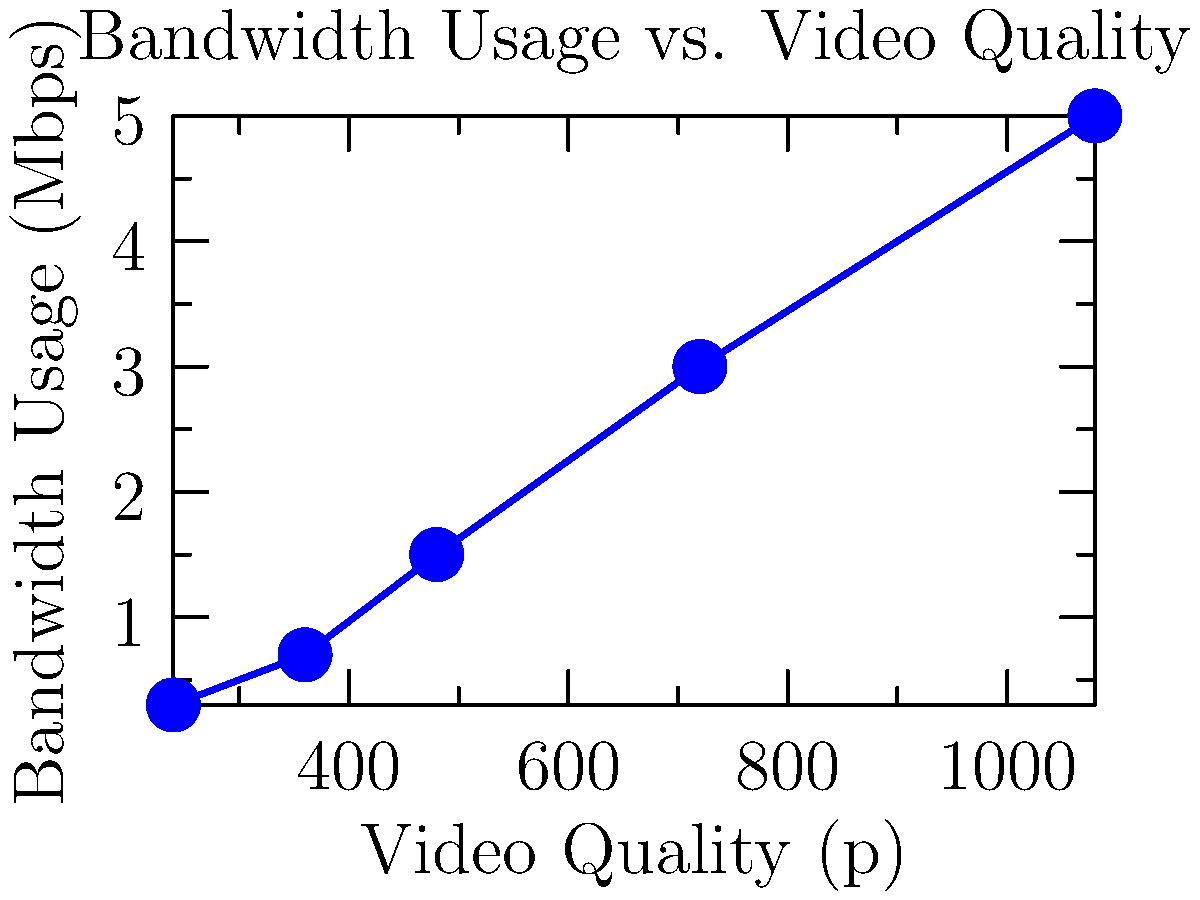Based on the graph showing bandwidth usage for different video quality levels in educational content streaming, what is the approximate percentage increase in bandwidth usage when moving from 480p to 720p quality? To calculate the percentage increase in bandwidth usage from 480p to 720p:

1. Identify bandwidth usage for 480p: 1.5 Mbps
2. Identify bandwidth usage for 720p: 3.0 Mbps
3. Calculate the difference: 3.0 - 1.5 = 1.5 Mbps
4. Calculate the percentage increase:
   $\frac{\text{Increase}}{\text{Original}} \times 100\% = \frac{1.5}{1.5} \times 100\% = 100\%$

The bandwidth usage doubles (increases by 100%) when moving from 480p to 720p quality.
Answer: 100% 